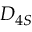Convert formula to latex. <formula><loc_0><loc_0><loc_500><loc_500>D _ { 4 S }</formula> 